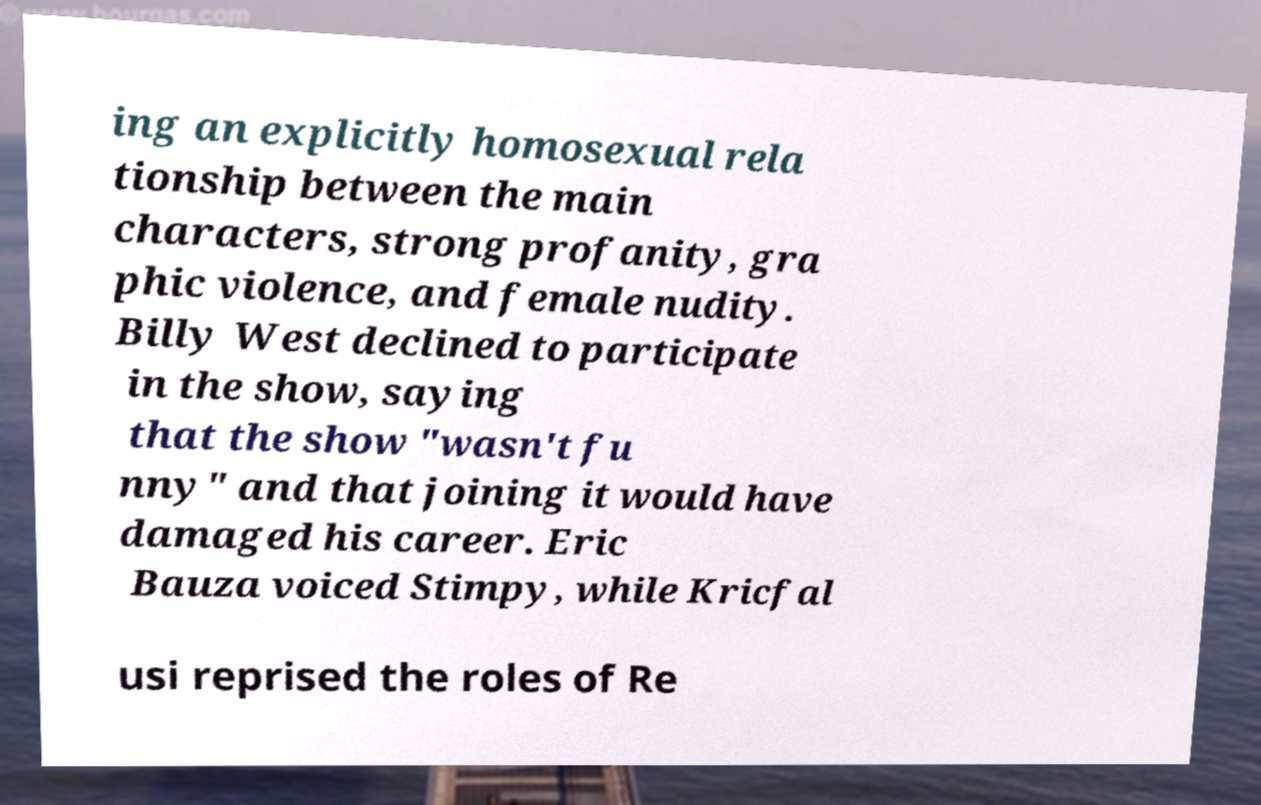Please identify and transcribe the text found in this image. ing an explicitly homosexual rela tionship between the main characters, strong profanity, gra phic violence, and female nudity. Billy West declined to participate in the show, saying that the show "wasn't fu nny" and that joining it would have damaged his career. Eric Bauza voiced Stimpy, while Kricfal usi reprised the roles of Re 